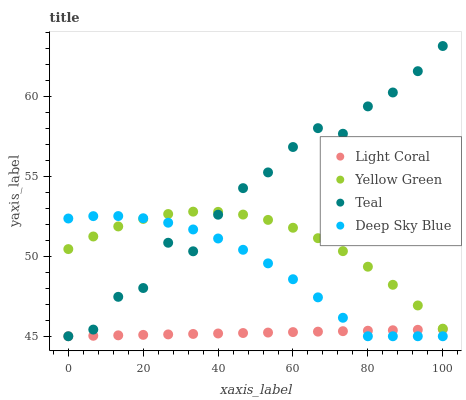Does Light Coral have the minimum area under the curve?
Answer yes or no. Yes. Does Teal have the maximum area under the curve?
Answer yes or no. Yes. Does Deep Sky Blue have the minimum area under the curve?
Answer yes or no. No. Does Deep Sky Blue have the maximum area under the curve?
Answer yes or no. No. Is Light Coral the smoothest?
Answer yes or no. Yes. Is Teal the roughest?
Answer yes or no. Yes. Is Deep Sky Blue the smoothest?
Answer yes or no. No. Is Deep Sky Blue the roughest?
Answer yes or no. No. Does Light Coral have the lowest value?
Answer yes or no. Yes. Does Yellow Green have the lowest value?
Answer yes or no. No. Does Teal have the highest value?
Answer yes or no. Yes. Does Deep Sky Blue have the highest value?
Answer yes or no. No. Is Light Coral less than Yellow Green?
Answer yes or no. Yes. Is Yellow Green greater than Light Coral?
Answer yes or no. Yes. Does Teal intersect Light Coral?
Answer yes or no. Yes. Is Teal less than Light Coral?
Answer yes or no. No. Is Teal greater than Light Coral?
Answer yes or no. No. Does Light Coral intersect Yellow Green?
Answer yes or no. No. 